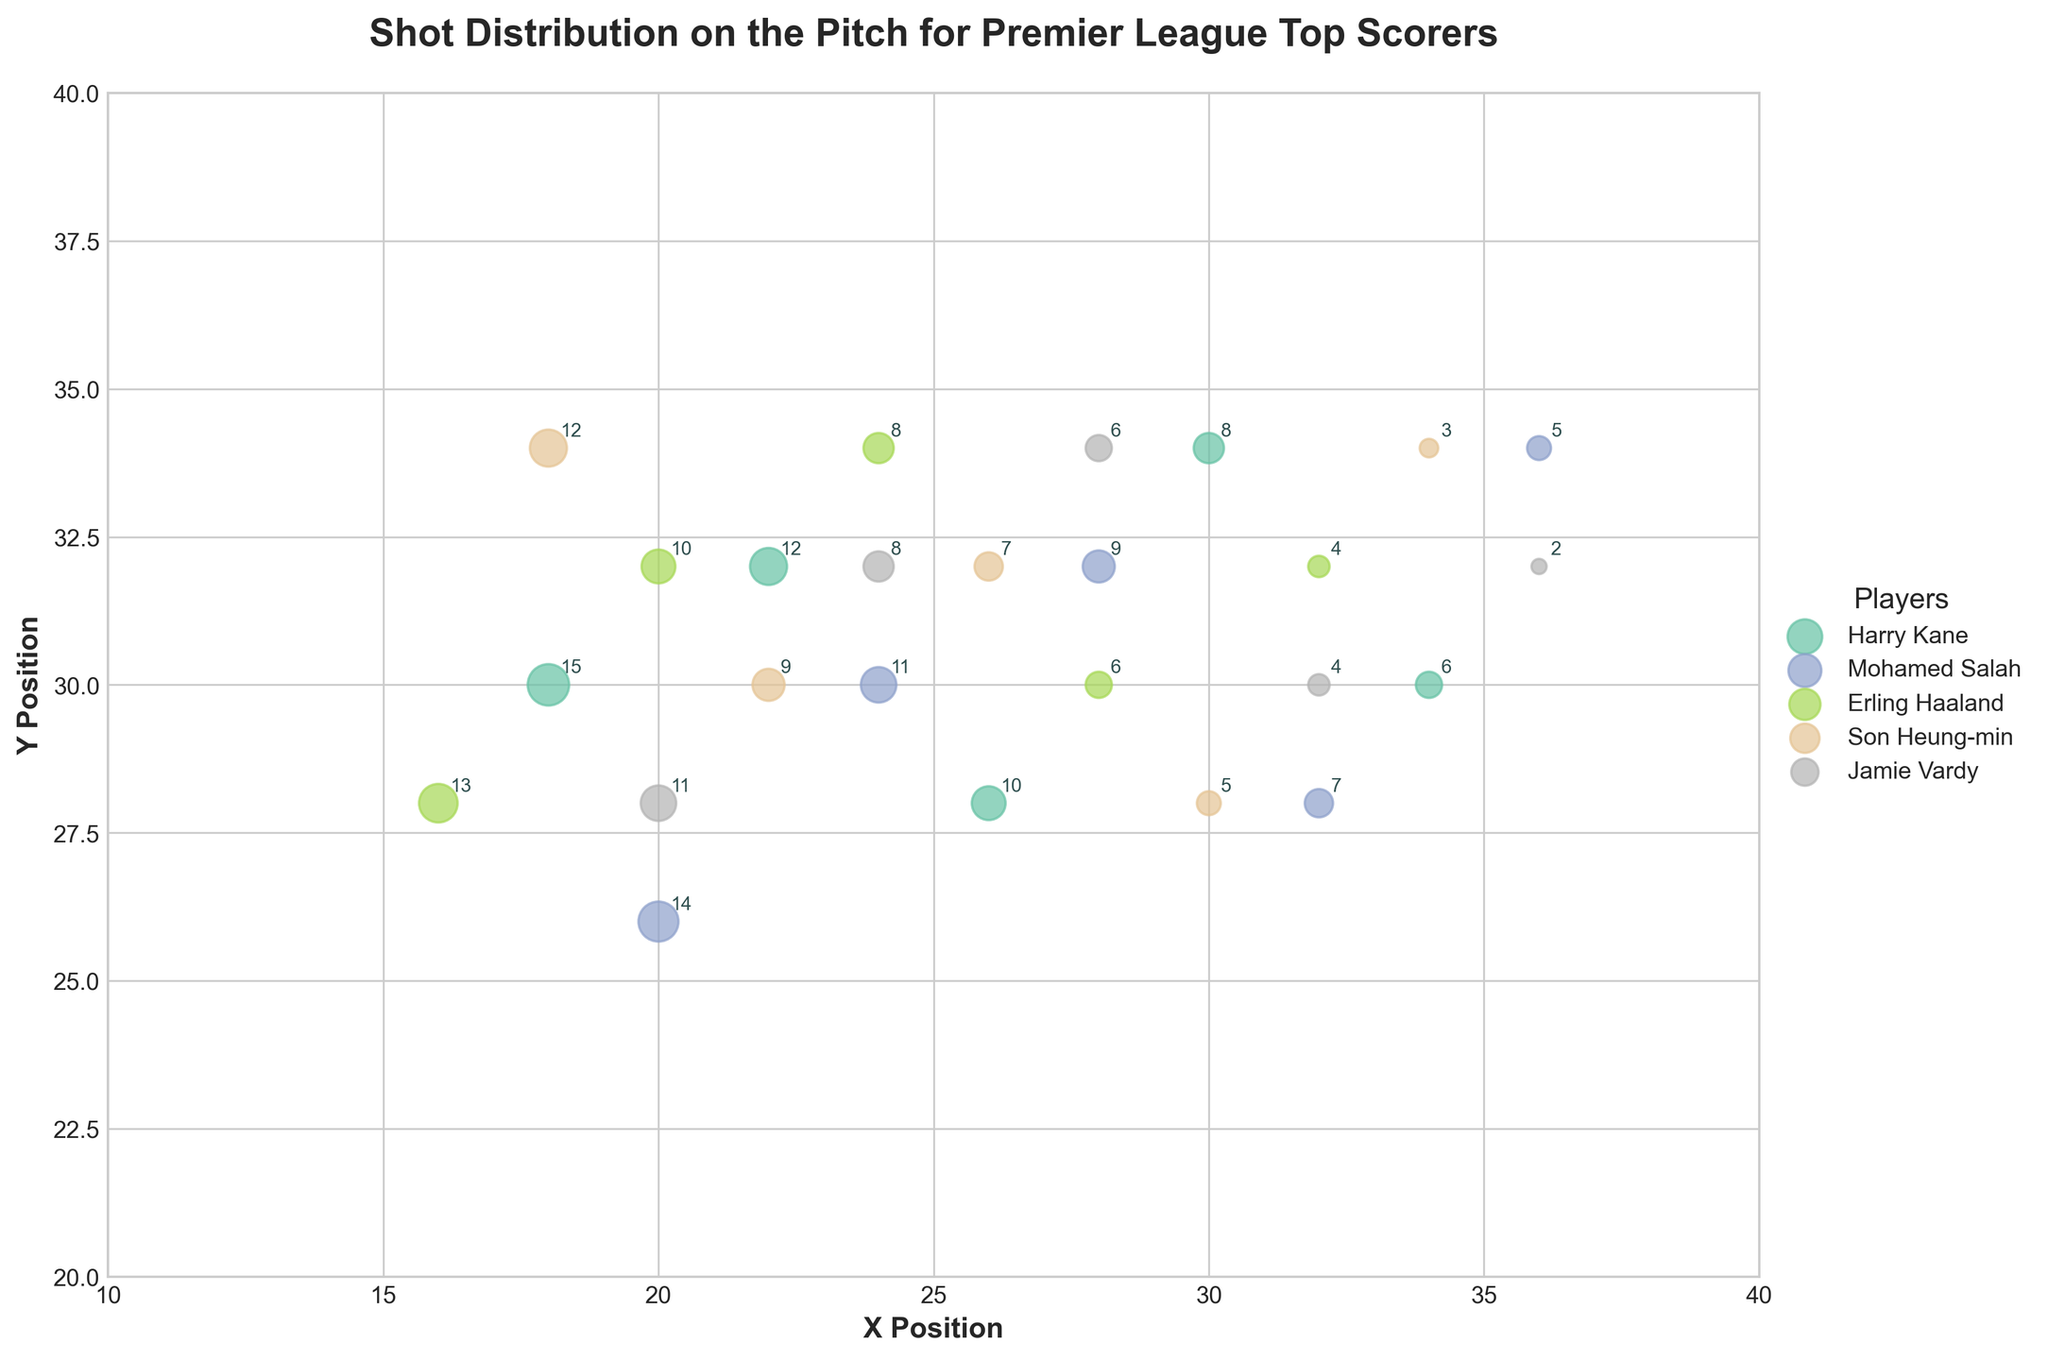How many players are represented in the plot? The plot contains a legend that lists each player. By counting the entries in the legend, we can see there are 5 players: Harry Kane, Mohamed Salah, Erling Haaland, Son Heung-min, and Jamie Vardy.
Answer: 5 Which player has the highest count for a single shot? We need to look for the largest number annotated on a data point in the plot. Harry Kane has a shot count of 15 at position (18, 30), which is the highest among all the players.
Answer: Harry Kane On which position does Mohamed Salah have the highest shot count? By examining the annotations for Mohamed Salah's data points, his highest count is 14 at position (20, 26).
Answer: (20, 26) Which two players have their highest shot count positioned closest to each other? We compare the coordinates of the highest shot counts for each player. Harry Kane’s highest count (15) is at (18, 30) and Mohamed Salah's highest count (14) is at (20, 26). The distance between these points is calculated as √((20-18)² + (26-30)²) = √(4 + 16) = √20, which is around 4.47 units. This seems the closest upon comparison.
Answer: Harry Kane and Mohamed Salah Does Erling Haaland have any shot counts positioned outside the 20 to 30 X Position range? To answer this, we can check Erling Haaland's annotated shot positions. His data points have X positions of 16, 20, 24, 28, and 32. Since 16 and 32 fall outside the 20 to 30 range, the answer is yes.
Answer: Yes Who has a shot count annotated at position (28, 32)? By examining the plot annotations, we can see that Mohamed Salah has a shot count of 9 at this position.
Answer: Mohamed Salah Compare the X distribution range (minimum and maximum) for Harry Kane and Son Heung-min. Whose range is wider? Harry Kane's X positions range from 18 to 34, giving a range of 34 - 18 = 16. Son Heung-min's X positions range from 18 to 34 as well. Both ranges are equal.
Answer: Equal What’s the total shot count for Jamie Vardy across all positions? Jamie Vardy’s counts are 11, 8, 6, 4, and 2. Summing these gives 11 + 8 + 6 + 4 + 2 = 31.
Answer: 31 Which player has a shot distribution most concentrated around the center of the plot (X=30, Y=30)? Observing the concentration around (30, 30), Harry Kane has multiple high counts (8 and 6) close to the center. Although several players have data points near the center, Harry Kane appears most concentrated in this area.
Answer: Harry Kane 